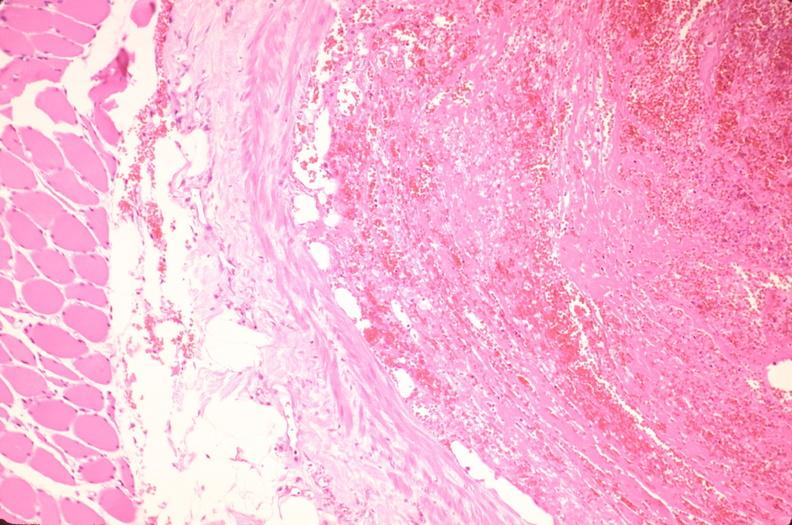where is this from?
Answer the question using a single word or phrase. Vasculature 